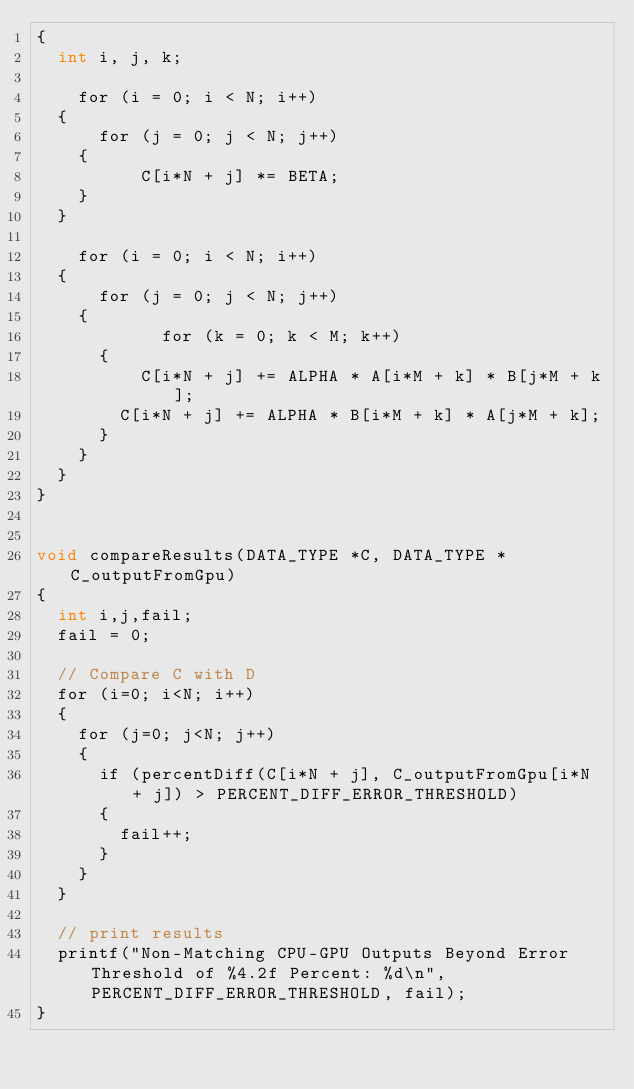<code> <loc_0><loc_0><loc_500><loc_500><_Cuda_>{
	int i, j, k;
		
  	for (i = 0; i < N; i++)
	{
   		for (j = 0; j < N; j++)
		{
     			C[i*N + j] *= BETA;
		}
	}

  	for (i = 0; i < N; i++)
	{
   		for (j = 0; j < N; j++)
		{
      			for (k = 0; k < M; k++)
			{
	  			C[i*N + j] += ALPHA * A[i*M + k] * B[j*M + k];
	 		 	C[i*N + j] += ALPHA * B[i*M + k] * A[j*M + k];
			}
		}
	}
}


void compareResults(DATA_TYPE *C, DATA_TYPE *C_outputFromGpu)
{
	int i,j,fail;
	fail = 0;

	// Compare C with D
	for (i=0; i<N; i++)
	{
		for (j=0; j<N; j++)
		{
			if (percentDiff(C[i*N + j], C_outputFromGpu[i*N + j]) > PERCENT_DIFF_ERROR_THRESHOLD)
			{ 
				fail++;
			}
		}
	}
	
	// print results
	printf("Non-Matching CPU-GPU Outputs Beyond Error Threshold of %4.2f Percent: %d\n", PERCENT_DIFF_ERROR_THRESHOLD, fail);
}

</code> 